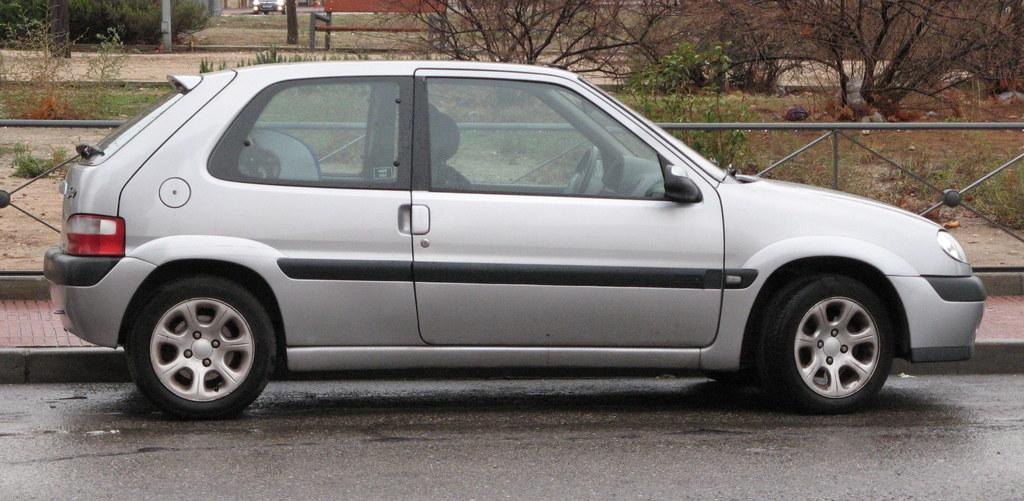What is the main subject of the image? There is a car in the image. Where is the car located? The car is on the road. What can be seen in the background of the image? There are trees visible in the background of the image. What type of hope can be seen growing on the trees in the image? There is no mention of hope or any type of plant growing on the trees in the image. The trees are simply visible in the background. 